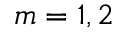<formula> <loc_0><loc_0><loc_500><loc_500>m = 1 , 2</formula> 